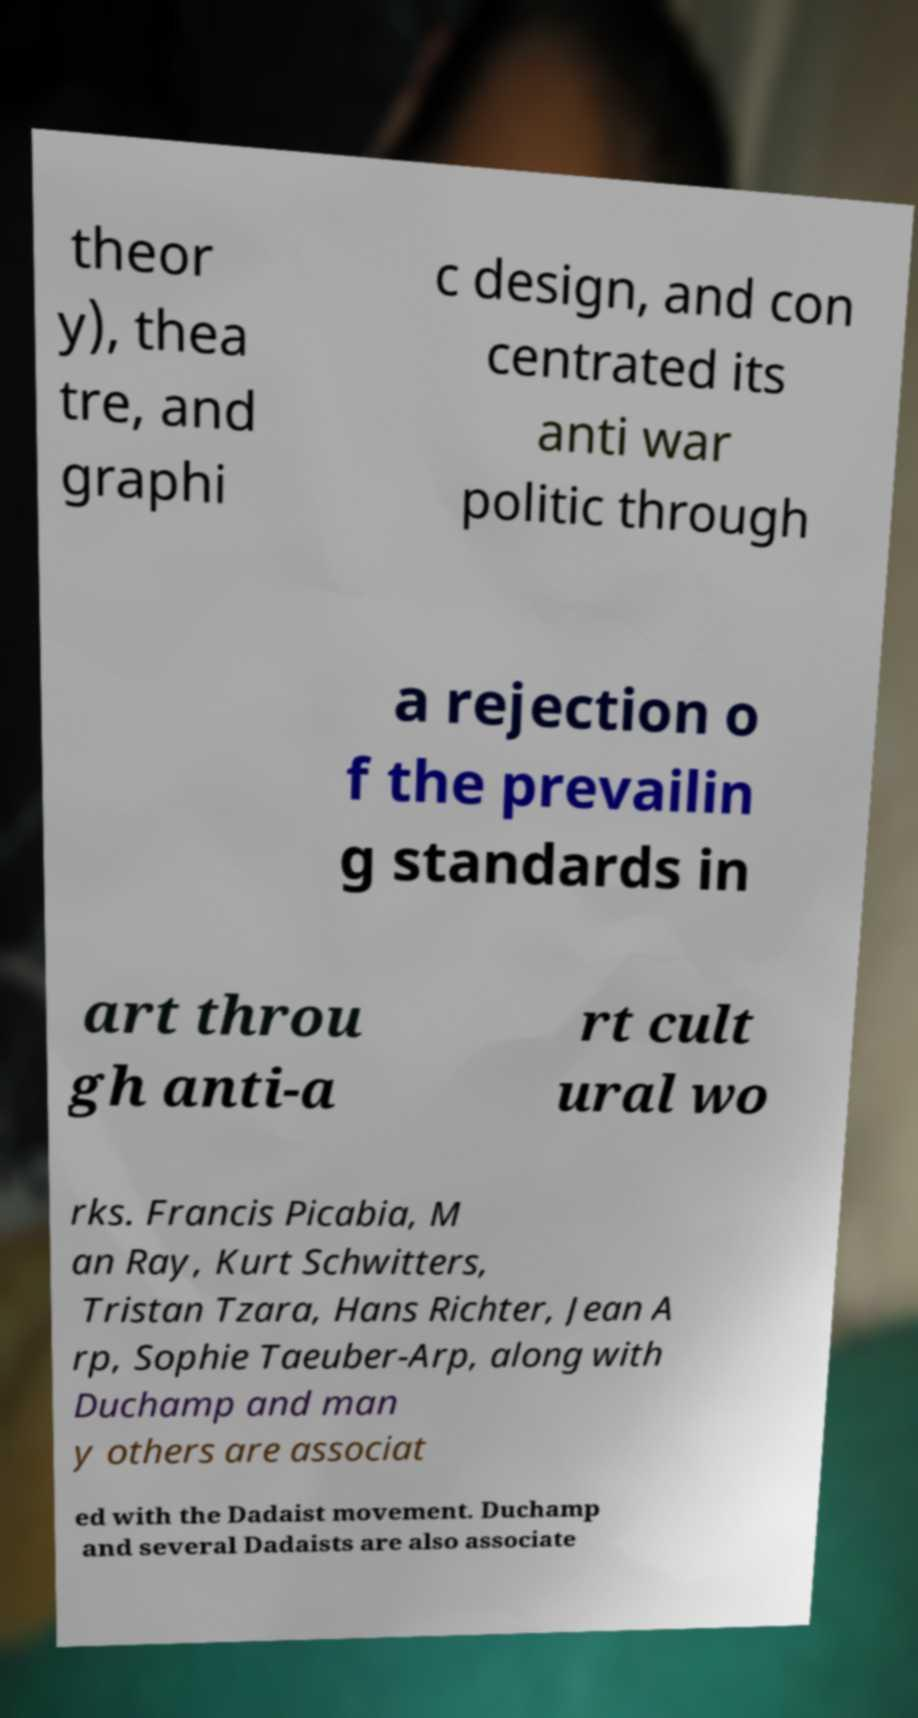Please read and relay the text visible in this image. What does it say? theor y), thea tre, and graphi c design, and con centrated its anti war politic through a rejection o f the prevailin g standards in art throu gh anti-a rt cult ural wo rks. Francis Picabia, M an Ray, Kurt Schwitters, Tristan Tzara, Hans Richter, Jean A rp, Sophie Taeuber-Arp, along with Duchamp and man y others are associat ed with the Dadaist movement. Duchamp and several Dadaists are also associate 